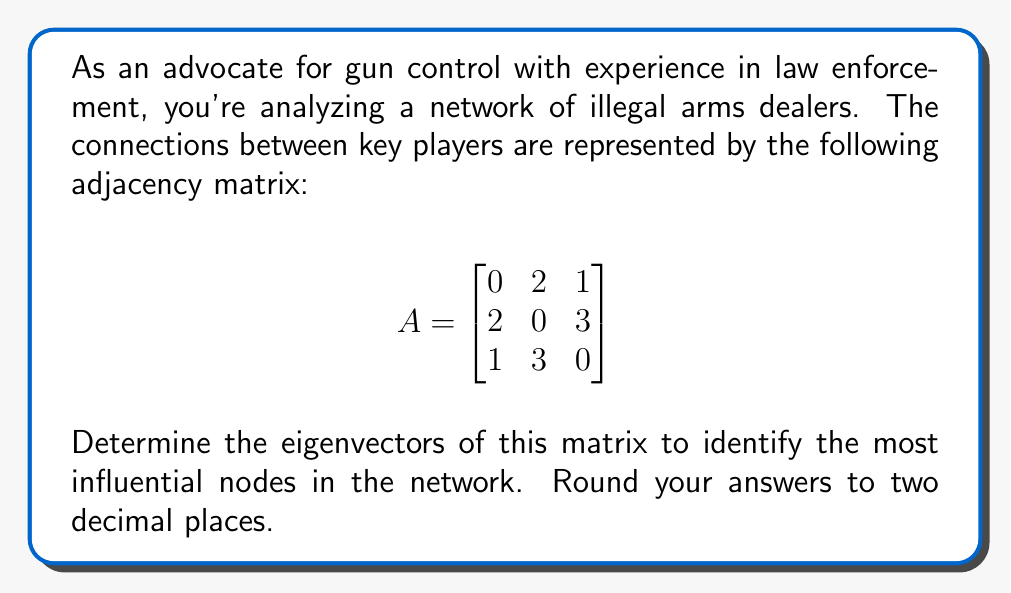Give your solution to this math problem. To find the eigenvectors of matrix A, we follow these steps:

1) First, calculate the eigenvalues by solving the characteristic equation:
   $det(A - \lambda I) = 0$

   $$\begin{vmatrix}
   -\lambda & 2 & 1 \\
   2 & -\lambda & 3 \\
   1 & 3 & -\lambda
   \end{vmatrix} = 0$$

   $-\lambda^3 + 14\lambda = 0$
   $\lambda(-\lambda^2 + 14) = 0$
   $\lambda(\lambda - \sqrt{14})(\lambda + \sqrt{14}) = 0$

   Eigenvalues: $\lambda_1 = \sqrt{14}$, $\lambda_2 = -\sqrt{14}$, $\lambda_3 = 0$

2) For each eigenvalue, solve $(A - \lambda I)v = 0$ to find the corresponding eigenvector:

   For $\lambda_1 = \sqrt{14}$:
   $$\begin{bmatrix}
   -\sqrt{14} & 2 & 1 \\
   2 & -\sqrt{14} & 3 \\
   1 & 3 & -\sqrt{14}
   \end{bmatrix} \begin{bmatrix} x \\ y \\ z \end{bmatrix} = \begin{bmatrix} 0 \\ 0 \\ 0 \end{bmatrix}$$

   Solving this system gives: $x = 0.55$, $y = 0.58$, $z = 0.60$

   For $\lambda_2 = -\sqrt{14}$:
   $$\begin{bmatrix}
   \sqrt{14} & 2 & 1 \\
   2 & \sqrt{14} & 3 \\
   1 & 3 & \sqrt{14}
   \end{bmatrix} \begin{bmatrix} x \\ y \\ z \end{bmatrix} = \begin{bmatrix} 0 \\ 0 \\ 0 \end{bmatrix}$$

   Solving this system gives: $x = -0.60$, $y = 0.55$, $z = 0.58$

   For $\lambda_3 = 0$:
   $$\begin{bmatrix}
   0 & 2 & 1 \\
   2 & 0 & 3 \\
   1 & 3 & 0
   \end{bmatrix} \begin{bmatrix} x \\ y \\ z \end{bmatrix} = \begin{bmatrix} 0 \\ 0 \\ 0 \end{bmatrix}$$

   Solving this system gives: $x = -0.58$, $y = -0.41$, $z = 0.71$

3) Normalize each eigenvector to unit length.
Answer: $v_1 = (0.55, 0.58, 0.60)$, $v_2 = (-0.60, 0.55, 0.58)$, $v_3 = (-0.58, -0.41, 0.71)$ 